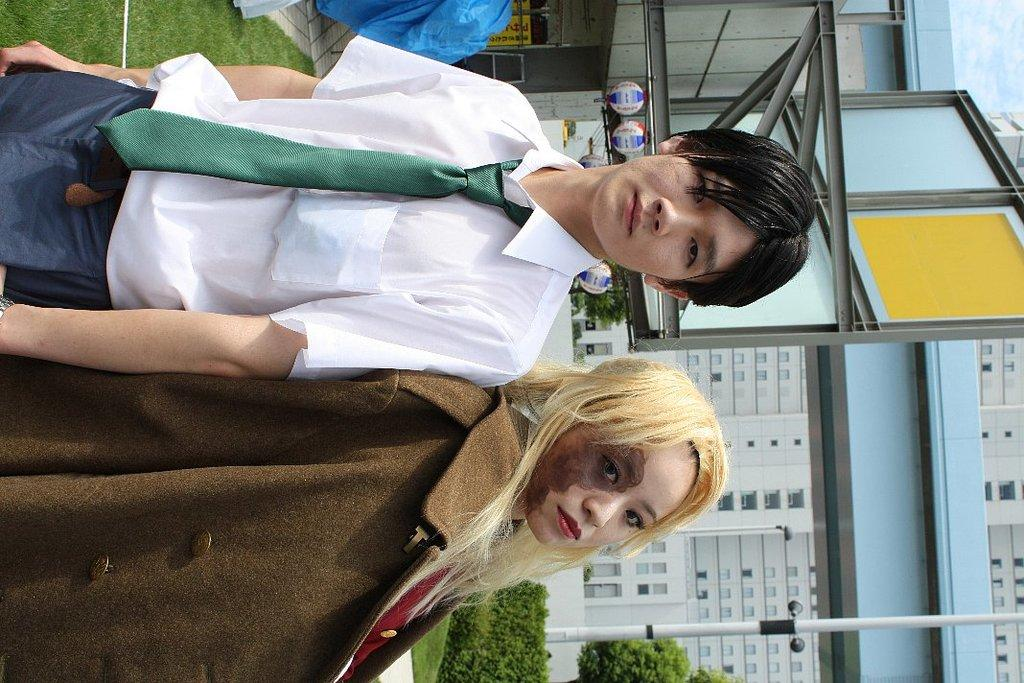How many people are in the image? There are two persons standing in the image. What can be seen in the background of the image? There is grass, plants, buildings, metal rods, and a pole in the background of the image. What time of day was the image taken? The image was taken during the day. What grade is the person on the left receiving in the image? There is no indication of a grade or any educational context in the image. Can you tell me how many toes the person on the right has in the image? There is no visible detail of the person's toes in the image. 